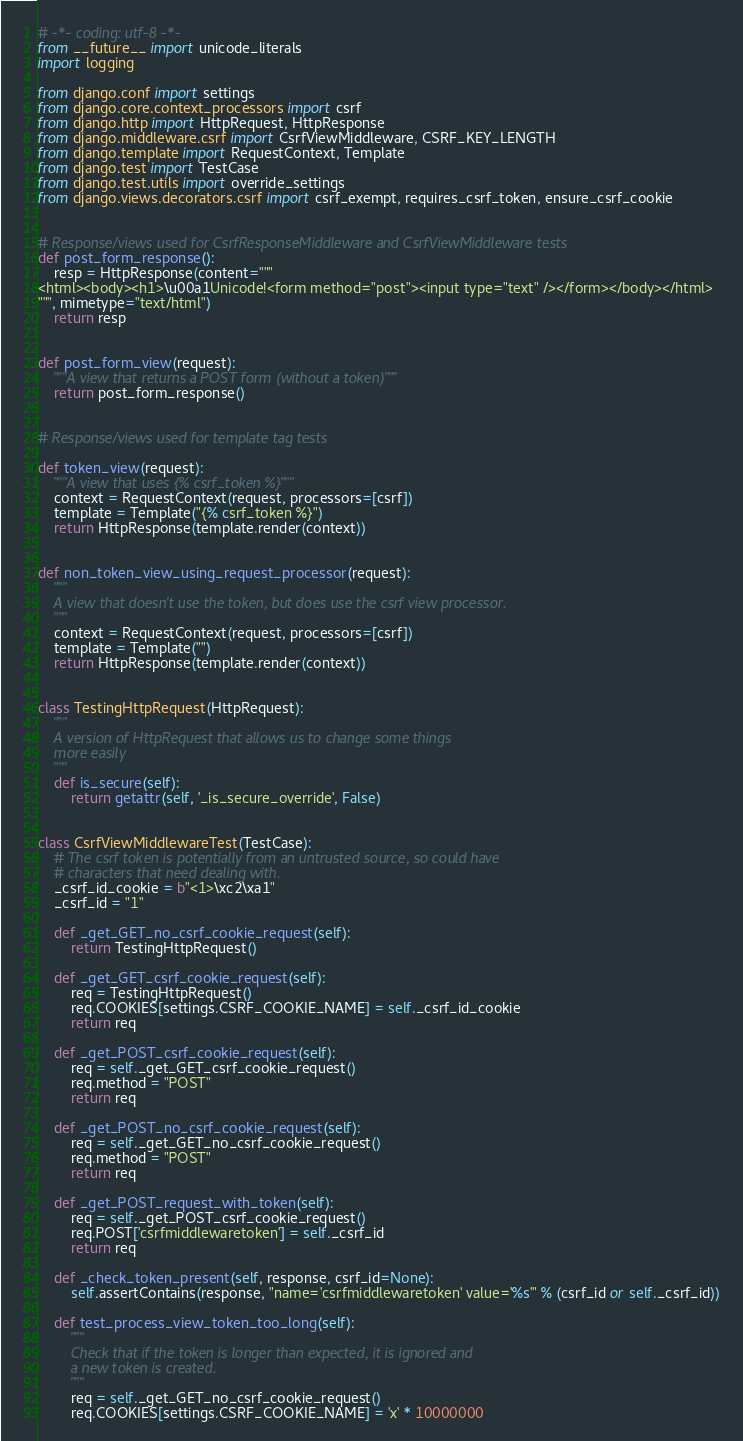<code> <loc_0><loc_0><loc_500><loc_500><_Python_># -*- coding: utf-8 -*-
from __future__ import unicode_literals
import logging

from django.conf import settings
from django.core.context_processors import csrf
from django.http import HttpRequest, HttpResponse
from django.middleware.csrf import CsrfViewMiddleware, CSRF_KEY_LENGTH
from django.template import RequestContext, Template
from django.test import TestCase
from django.test.utils import override_settings
from django.views.decorators.csrf import csrf_exempt, requires_csrf_token, ensure_csrf_cookie


# Response/views used for CsrfResponseMiddleware and CsrfViewMiddleware tests
def post_form_response():
    resp = HttpResponse(content="""
<html><body><h1>\u00a1Unicode!<form method="post"><input type="text" /></form></body></html>
""", mimetype="text/html")
    return resp


def post_form_view(request):
    """A view that returns a POST form (without a token)"""
    return post_form_response()


# Response/views used for template tag tests

def token_view(request):
    """A view that uses {% csrf_token %}"""
    context = RequestContext(request, processors=[csrf])
    template = Template("{% csrf_token %}")
    return HttpResponse(template.render(context))


def non_token_view_using_request_processor(request):
    """
    A view that doesn't use the token, but does use the csrf view processor.
    """
    context = RequestContext(request, processors=[csrf])
    template = Template("")
    return HttpResponse(template.render(context))


class TestingHttpRequest(HttpRequest):
    """
    A version of HttpRequest that allows us to change some things
    more easily
    """
    def is_secure(self):
        return getattr(self, '_is_secure_override', False)


class CsrfViewMiddlewareTest(TestCase):
    # The csrf token is potentially from an untrusted source, so could have
    # characters that need dealing with.
    _csrf_id_cookie = b"<1>\xc2\xa1"
    _csrf_id = "1"

    def _get_GET_no_csrf_cookie_request(self):
        return TestingHttpRequest()

    def _get_GET_csrf_cookie_request(self):
        req = TestingHttpRequest()
        req.COOKIES[settings.CSRF_COOKIE_NAME] = self._csrf_id_cookie
        return req

    def _get_POST_csrf_cookie_request(self):
        req = self._get_GET_csrf_cookie_request()
        req.method = "POST"
        return req

    def _get_POST_no_csrf_cookie_request(self):
        req = self._get_GET_no_csrf_cookie_request()
        req.method = "POST"
        return req

    def _get_POST_request_with_token(self):
        req = self._get_POST_csrf_cookie_request()
        req.POST['csrfmiddlewaretoken'] = self._csrf_id
        return req

    def _check_token_present(self, response, csrf_id=None):
        self.assertContains(response, "name='csrfmiddlewaretoken' value='%s'" % (csrf_id or self._csrf_id))

    def test_process_view_token_too_long(self):
        """
        Check that if the token is longer than expected, it is ignored and
        a new token is created.
        """
        req = self._get_GET_no_csrf_cookie_request()
        req.COOKIES[settings.CSRF_COOKIE_NAME] = 'x' * 10000000</code> 